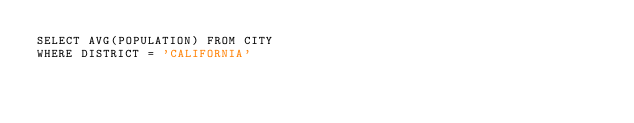<code> <loc_0><loc_0><loc_500><loc_500><_SQL_>SELECT AVG(POPULATION) FROM CITY
WHERE DISTRICT = 'CALIFORNIA'</code> 